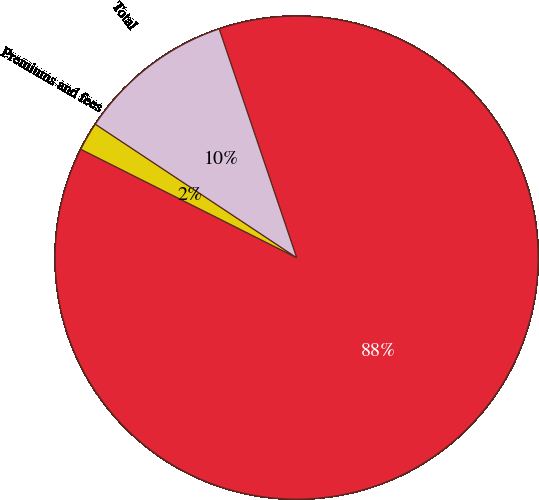Convert chart. <chart><loc_0><loc_0><loc_500><loc_500><pie_chart><fcel>(in millions)<fcel>Premiums and fees<fcel>Total<nl><fcel>87.6%<fcel>1.91%<fcel>10.48%<nl></chart> 